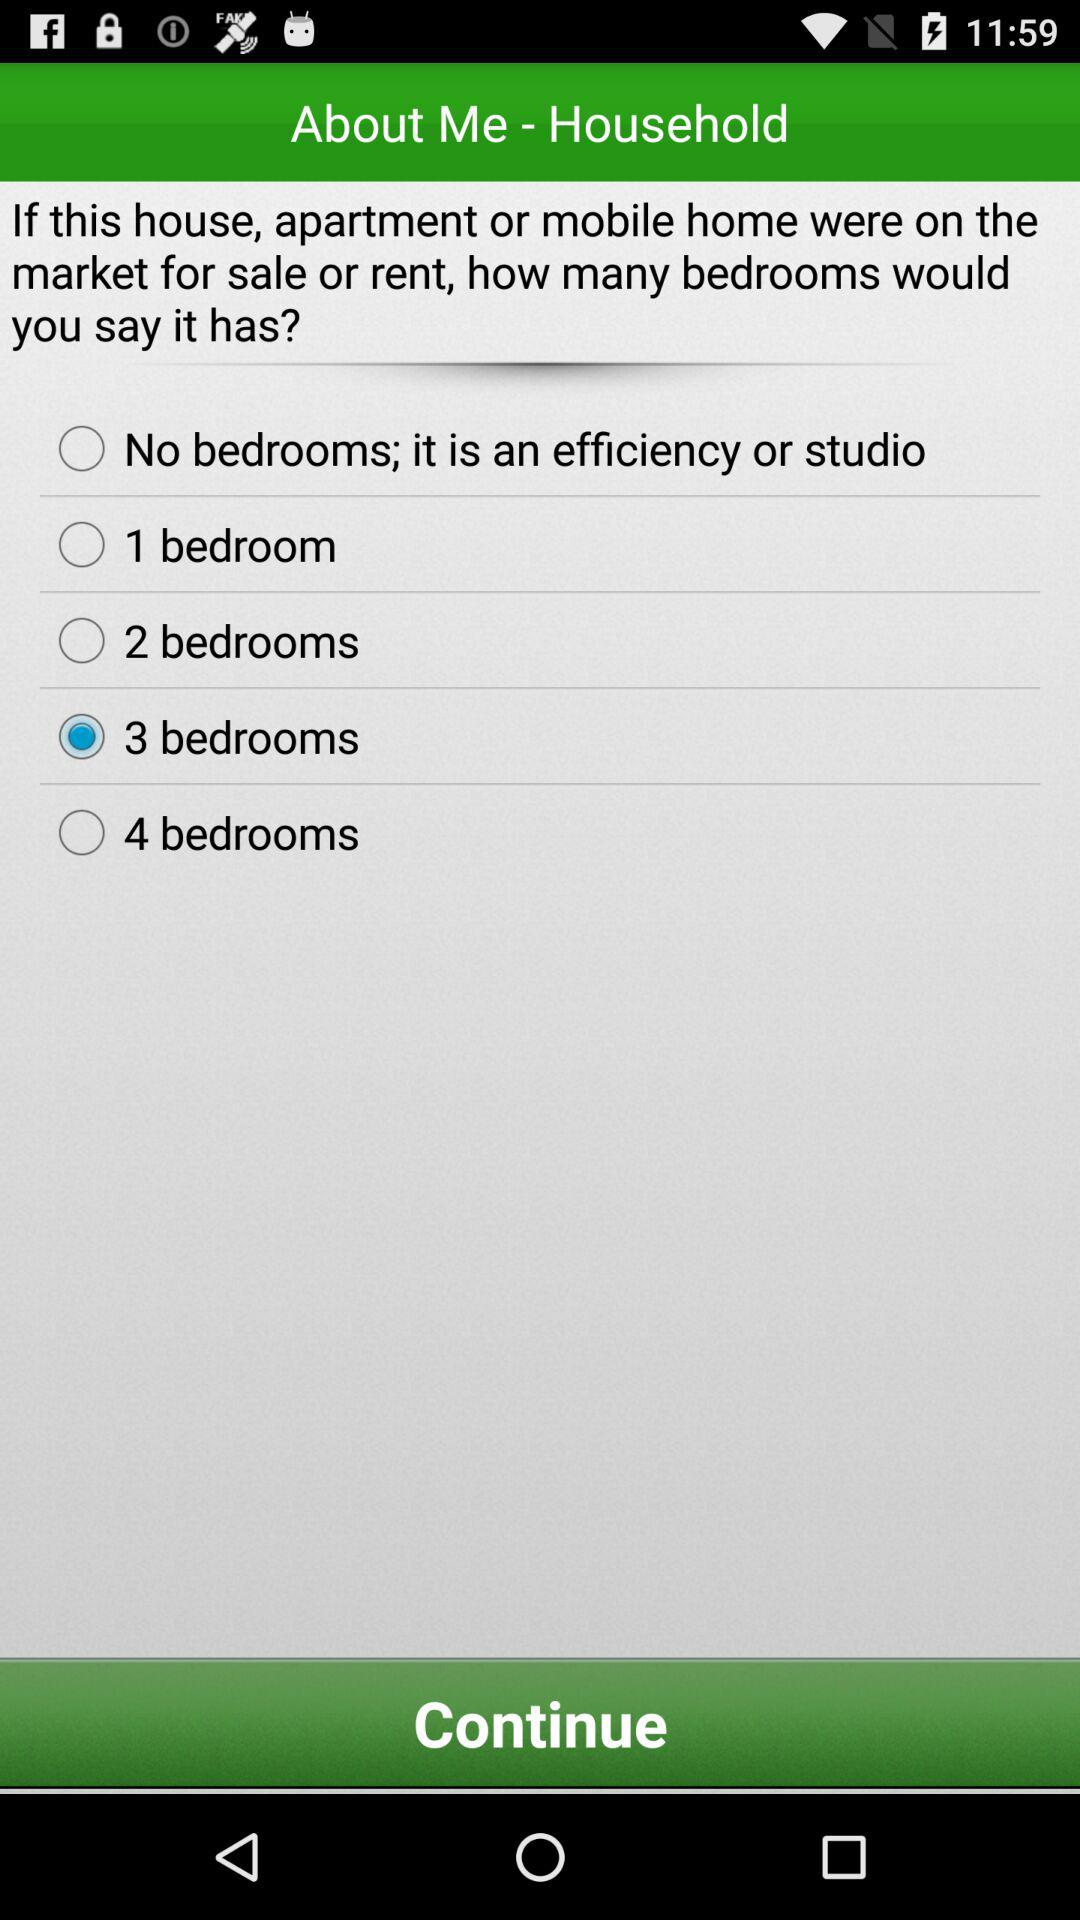What is the selected number of bedrooms? The selected number of bedrooms is 3. 